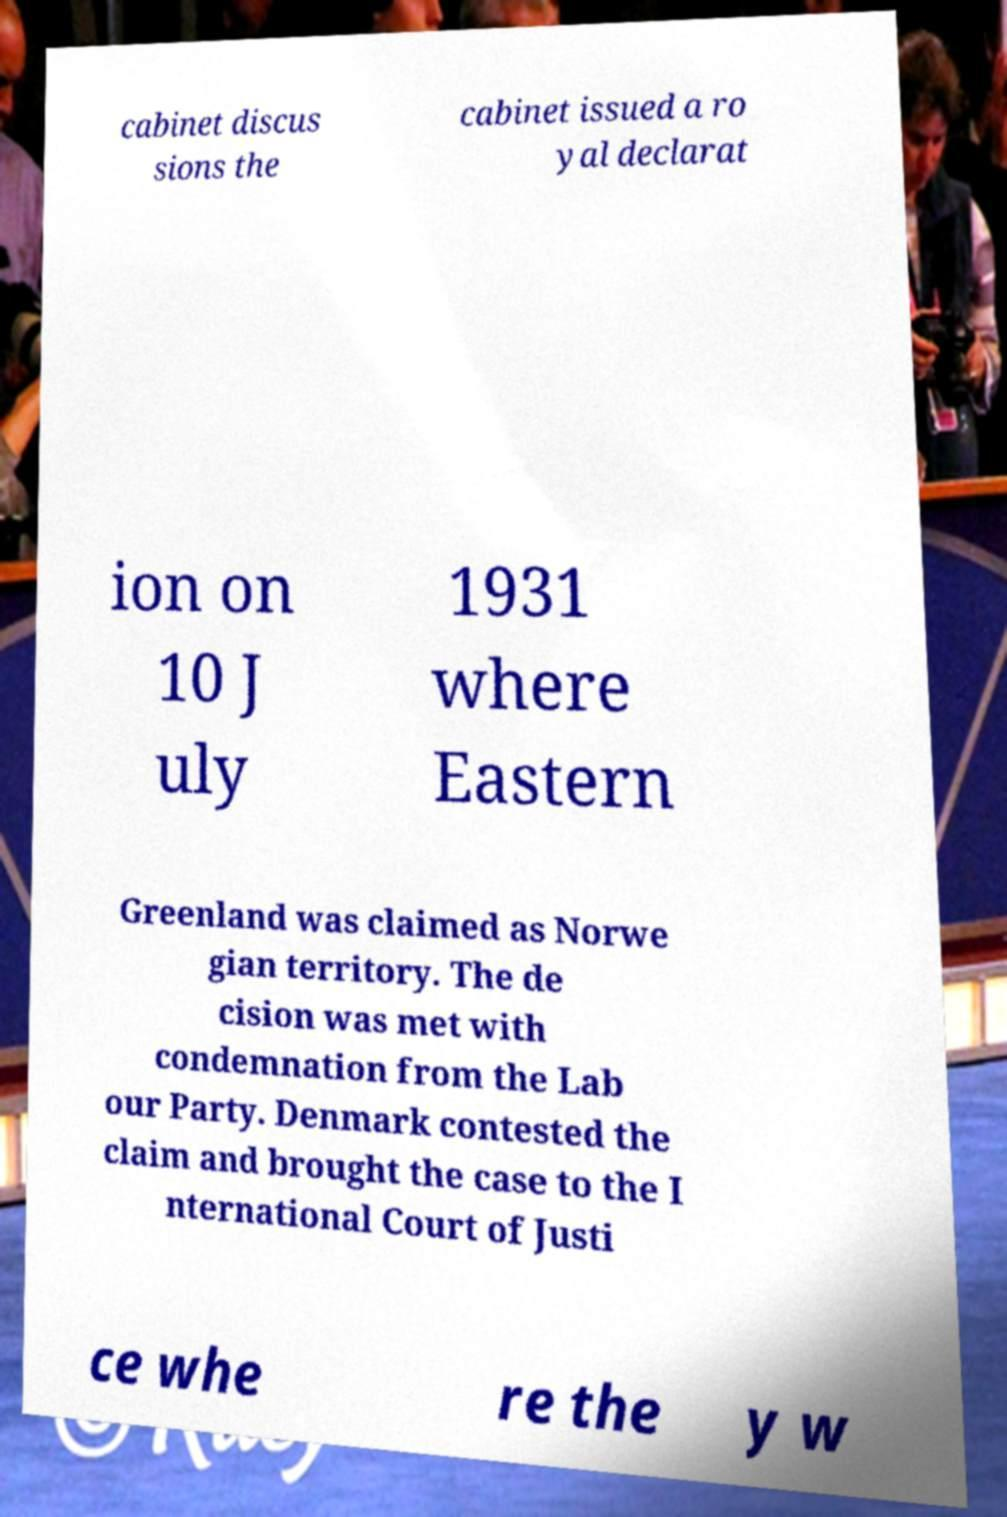I need the written content from this picture converted into text. Can you do that? cabinet discus sions the cabinet issued a ro yal declarat ion on 10 J uly 1931 where Eastern Greenland was claimed as Norwe gian territory. The de cision was met with condemnation from the Lab our Party. Denmark contested the claim and brought the case to the I nternational Court of Justi ce whe re the y w 